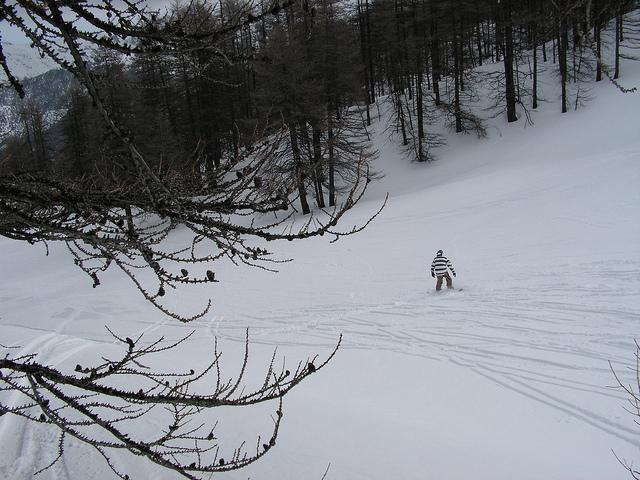What are the little bumps on the tree branches?

Choices:
A) insects
B) leaves
C) seed cones
D) hives seed cones 